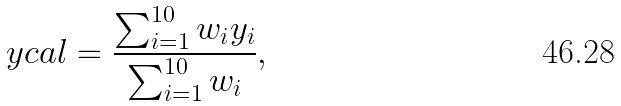Convert formula to latex. <formula><loc_0><loc_0><loc_500><loc_500>\ y c a l = \frac { \sum _ { i = 1 } ^ { 1 0 } w _ { i } y _ { i } } { \sum _ { i = 1 } ^ { 1 0 } w _ { i } } ,</formula> 